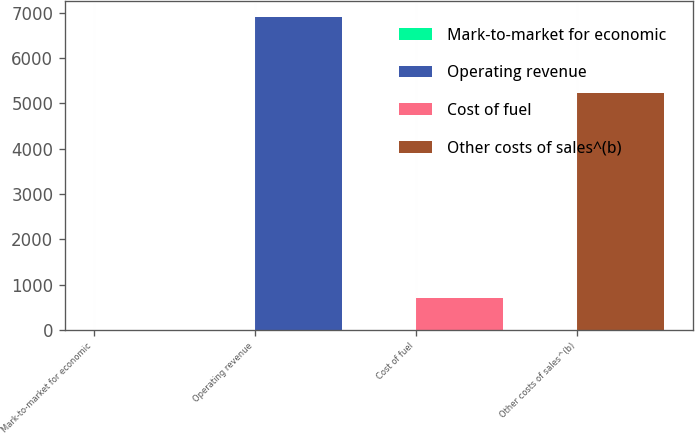<chart> <loc_0><loc_0><loc_500><loc_500><bar_chart><fcel>Mark-to-market for economic<fcel>Operating revenue<fcel>Cost of fuel<fcel>Other costs of sales^(b)<nl><fcel>4<fcel>6913<fcel>694.9<fcel>5236<nl></chart> 